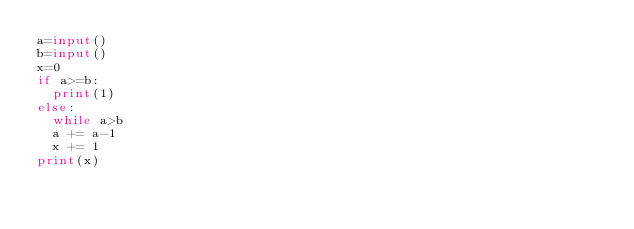Convert code to text. <code><loc_0><loc_0><loc_500><loc_500><_Python_>a=input()
b=input()
x=0
if a>=b:
  print(1)
else:
  while a>b
  a += a-1
  x += 1
print(x)</code> 